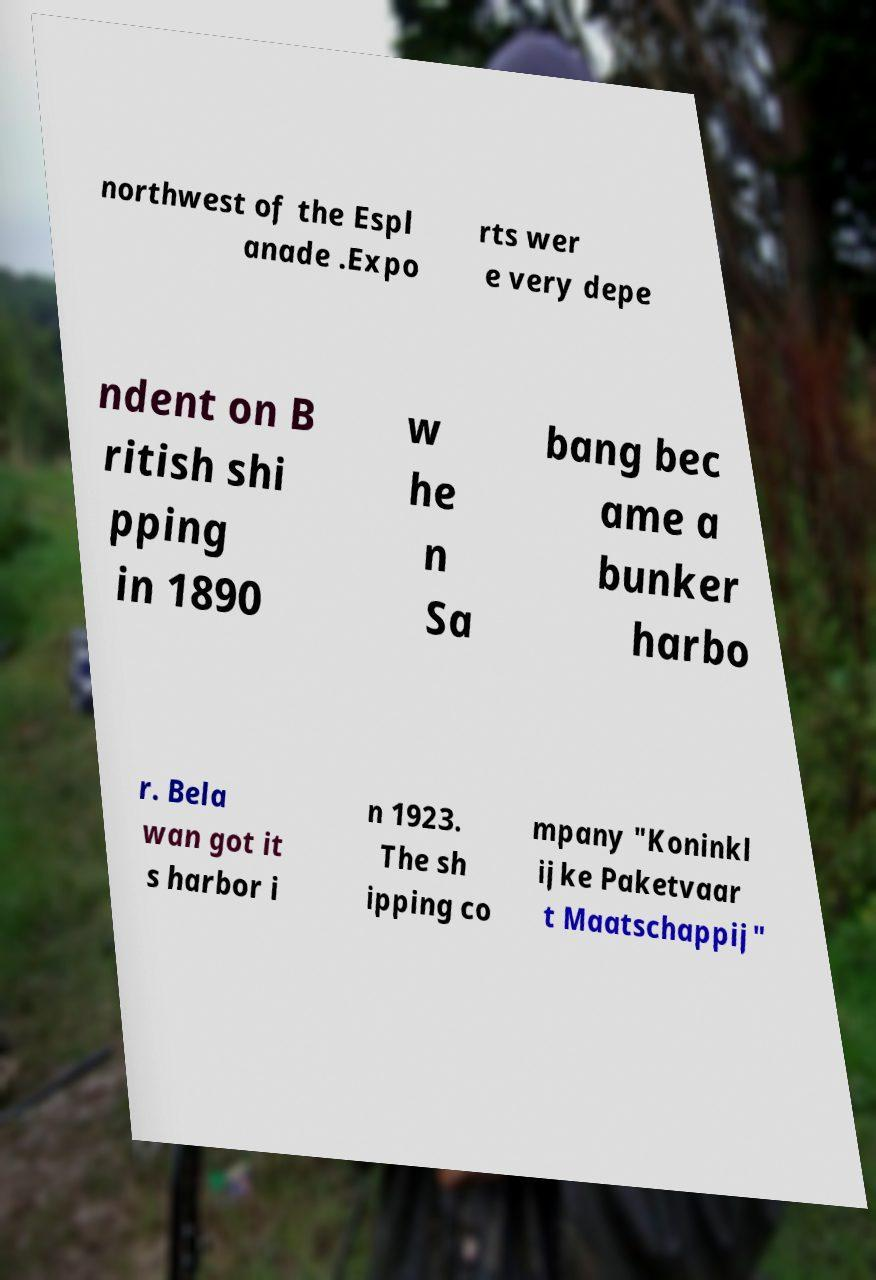Can you accurately transcribe the text from the provided image for me? northwest of the Espl anade .Expo rts wer e very depe ndent on B ritish shi pping in 1890 w he n Sa bang bec ame a bunker harbo r. Bela wan got it s harbor i n 1923. The sh ipping co mpany "Koninkl ijke Paketvaar t Maatschappij" 